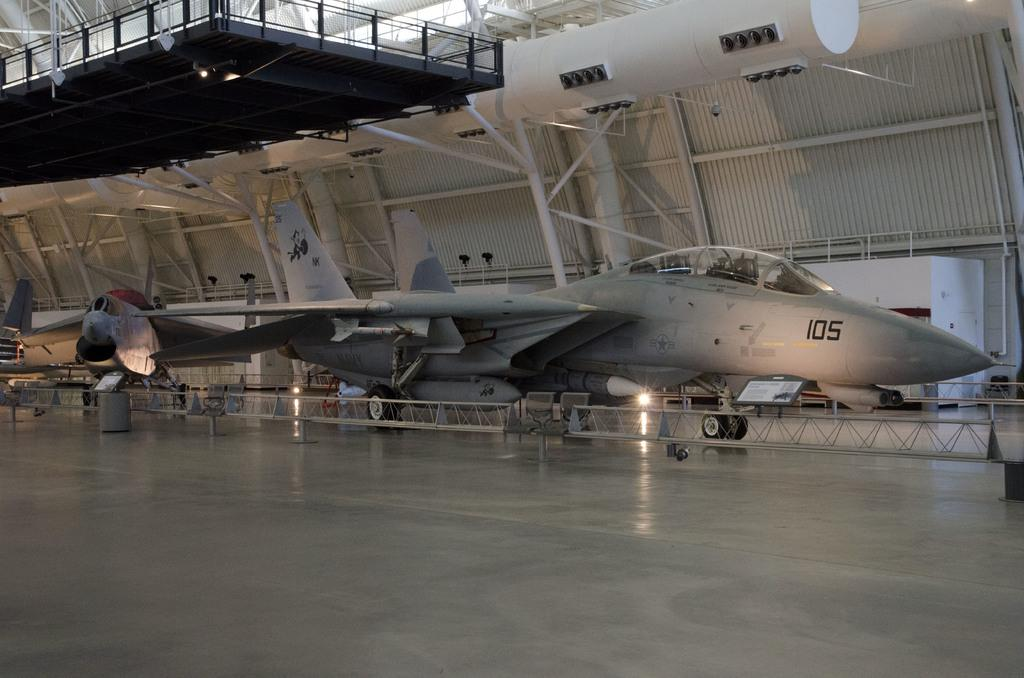Provide a one-sentence caption for the provided image. a plane with the number 105 on the side of it. 